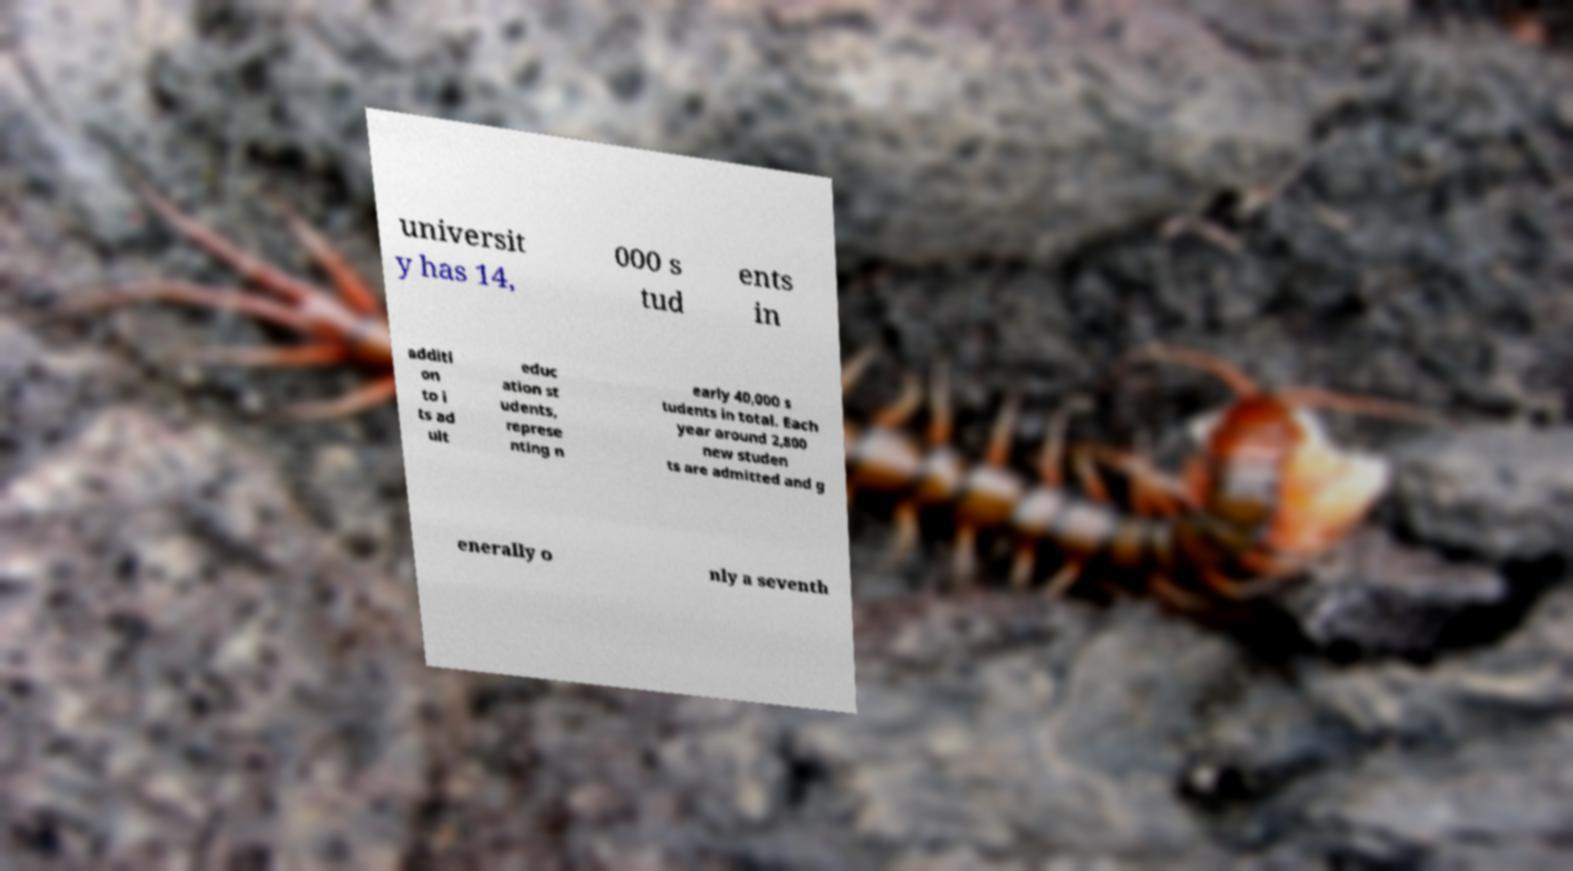Can you accurately transcribe the text from the provided image for me? universit y has 14, 000 s tud ents in additi on to i ts ad ult educ ation st udents, represe nting n early 40,000 s tudents in total. Each year around 2,800 new studen ts are admitted and g enerally o nly a seventh 